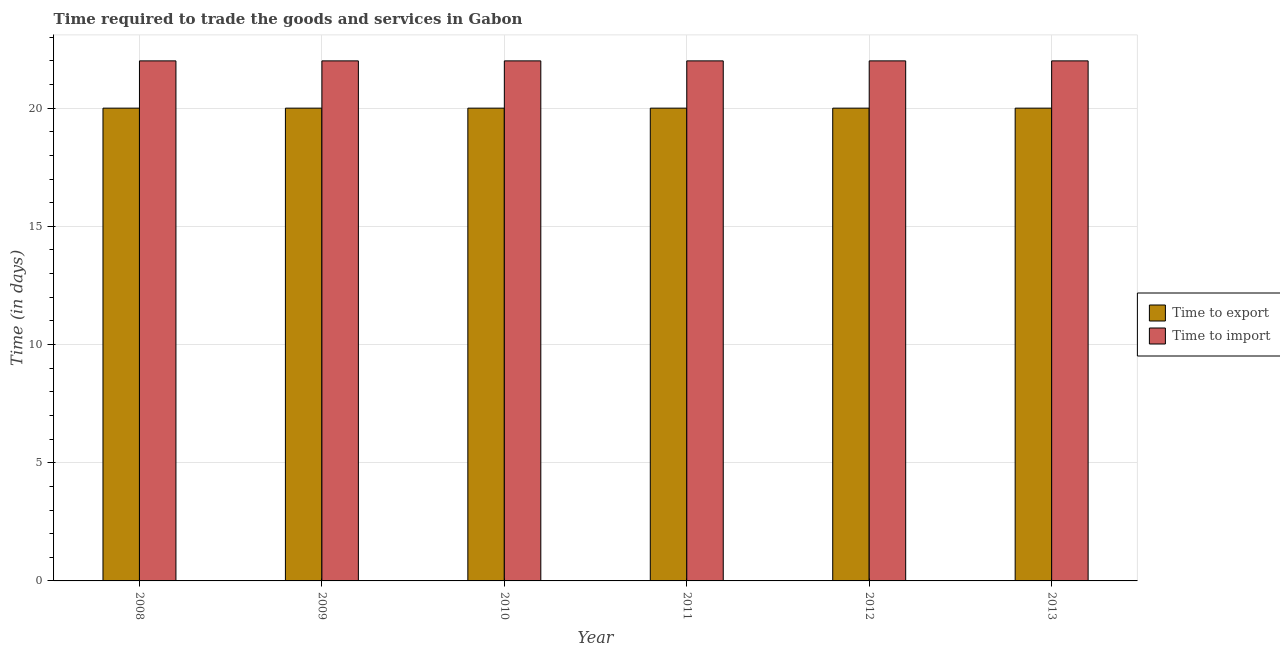How many different coloured bars are there?
Your answer should be very brief. 2. How many groups of bars are there?
Give a very brief answer. 6. Are the number of bars per tick equal to the number of legend labels?
Provide a succinct answer. Yes. How many bars are there on the 1st tick from the right?
Your answer should be compact. 2. What is the time to export in 2011?
Provide a short and direct response. 20. Across all years, what is the maximum time to export?
Keep it short and to the point. 20. Across all years, what is the minimum time to export?
Your response must be concise. 20. In which year was the time to import maximum?
Make the answer very short. 2008. In which year was the time to export minimum?
Your answer should be very brief. 2008. What is the total time to import in the graph?
Ensure brevity in your answer.  132. What is the average time to export per year?
Provide a short and direct response. 20. In how many years, is the time to import greater than 15 days?
Offer a terse response. 6. Is the time to import in 2011 less than that in 2013?
Ensure brevity in your answer.  No. Is the difference between the time to export in 2010 and 2012 greater than the difference between the time to import in 2010 and 2012?
Ensure brevity in your answer.  No. What is the difference between the highest and the second highest time to export?
Provide a succinct answer. 0. What is the difference between the highest and the lowest time to import?
Your answer should be compact. 0. Is the sum of the time to import in 2012 and 2013 greater than the maximum time to export across all years?
Your answer should be compact. Yes. What does the 1st bar from the left in 2008 represents?
Give a very brief answer. Time to export. What does the 1st bar from the right in 2010 represents?
Ensure brevity in your answer.  Time to import. What is the difference between two consecutive major ticks on the Y-axis?
Offer a terse response. 5. Where does the legend appear in the graph?
Keep it short and to the point. Center right. How many legend labels are there?
Give a very brief answer. 2. What is the title of the graph?
Make the answer very short. Time required to trade the goods and services in Gabon. Does "Primary completion rate" appear as one of the legend labels in the graph?
Your answer should be very brief. No. What is the label or title of the X-axis?
Offer a terse response. Year. What is the label or title of the Y-axis?
Provide a succinct answer. Time (in days). What is the Time (in days) in Time to export in 2009?
Your response must be concise. 20. What is the Time (in days) of Time to import in 2010?
Provide a short and direct response. 22. What is the Time (in days) in Time to import in 2011?
Offer a very short reply. 22. What is the Time (in days) in Time to import in 2012?
Provide a succinct answer. 22. What is the Time (in days) in Time to import in 2013?
Make the answer very short. 22. Across all years, what is the maximum Time (in days) in Time to export?
Ensure brevity in your answer.  20. Across all years, what is the minimum Time (in days) in Time to import?
Offer a very short reply. 22. What is the total Time (in days) of Time to export in the graph?
Provide a short and direct response. 120. What is the total Time (in days) in Time to import in the graph?
Offer a very short reply. 132. What is the difference between the Time (in days) of Time to export in 2008 and that in 2009?
Provide a succinct answer. 0. What is the difference between the Time (in days) of Time to import in 2008 and that in 2009?
Offer a very short reply. 0. What is the difference between the Time (in days) in Time to export in 2008 and that in 2010?
Give a very brief answer. 0. What is the difference between the Time (in days) of Time to export in 2008 and that in 2011?
Give a very brief answer. 0. What is the difference between the Time (in days) of Time to import in 2008 and that in 2012?
Ensure brevity in your answer.  0. What is the difference between the Time (in days) in Time to import in 2008 and that in 2013?
Your response must be concise. 0. What is the difference between the Time (in days) in Time to import in 2009 and that in 2011?
Your answer should be very brief. 0. What is the difference between the Time (in days) of Time to export in 2009 and that in 2012?
Make the answer very short. 0. What is the difference between the Time (in days) of Time to export in 2009 and that in 2013?
Provide a succinct answer. 0. What is the difference between the Time (in days) in Time to export in 2010 and that in 2011?
Your response must be concise. 0. What is the difference between the Time (in days) of Time to import in 2010 and that in 2012?
Offer a very short reply. 0. What is the difference between the Time (in days) in Time to export in 2010 and that in 2013?
Offer a terse response. 0. What is the difference between the Time (in days) in Time to import in 2010 and that in 2013?
Ensure brevity in your answer.  0. What is the difference between the Time (in days) in Time to import in 2011 and that in 2012?
Keep it short and to the point. 0. What is the difference between the Time (in days) of Time to import in 2011 and that in 2013?
Your answer should be very brief. 0. What is the difference between the Time (in days) in Time to import in 2012 and that in 2013?
Give a very brief answer. 0. What is the difference between the Time (in days) in Time to export in 2008 and the Time (in days) in Time to import in 2011?
Make the answer very short. -2. What is the difference between the Time (in days) of Time to export in 2008 and the Time (in days) of Time to import in 2013?
Make the answer very short. -2. What is the difference between the Time (in days) of Time to export in 2009 and the Time (in days) of Time to import in 2011?
Provide a succinct answer. -2. What is the difference between the Time (in days) of Time to export in 2010 and the Time (in days) of Time to import in 2012?
Provide a succinct answer. -2. What is the difference between the Time (in days) of Time to export in 2010 and the Time (in days) of Time to import in 2013?
Ensure brevity in your answer.  -2. What is the difference between the Time (in days) in Time to export in 2012 and the Time (in days) in Time to import in 2013?
Provide a short and direct response. -2. What is the average Time (in days) in Time to import per year?
Offer a terse response. 22. In the year 2008, what is the difference between the Time (in days) in Time to export and Time (in days) in Time to import?
Provide a short and direct response. -2. In the year 2010, what is the difference between the Time (in days) of Time to export and Time (in days) of Time to import?
Provide a succinct answer. -2. In the year 2012, what is the difference between the Time (in days) of Time to export and Time (in days) of Time to import?
Your response must be concise. -2. What is the ratio of the Time (in days) of Time to export in 2008 to that in 2009?
Offer a very short reply. 1. What is the ratio of the Time (in days) in Time to import in 2008 to that in 2009?
Your answer should be very brief. 1. What is the ratio of the Time (in days) of Time to export in 2008 to that in 2012?
Ensure brevity in your answer.  1. What is the ratio of the Time (in days) in Time to import in 2008 to that in 2012?
Give a very brief answer. 1. What is the ratio of the Time (in days) of Time to export in 2008 to that in 2013?
Make the answer very short. 1. What is the ratio of the Time (in days) of Time to export in 2009 to that in 2010?
Provide a short and direct response. 1. What is the ratio of the Time (in days) of Time to import in 2009 to that in 2010?
Keep it short and to the point. 1. What is the ratio of the Time (in days) in Time to import in 2009 to that in 2011?
Provide a succinct answer. 1. What is the ratio of the Time (in days) of Time to import in 2010 to that in 2011?
Make the answer very short. 1. What is the ratio of the Time (in days) in Time to export in 2010 to that in 2012?
Offer a terse response. 1. What is the ratio of the Time (in days) in Time to import in 2010 to that in 2012?
Provide a short and direct response. 1. What is the ratio of the Time (in days) in Time to import in 2010 to that in 2013?
Ensure brevity in your answer.  1. What is the ratio of the Time (in days) of Time to export in 2012 to that in 2013?
Ensure brevity in your answer.  1. What is the ratio of the Time (in days) in Time to import in 2012 to that in 2013?
Offer a very short reply. 1. What is the difference between the highest and the second highest Time (in days) of Time to export?
Offer a terse response. 0. 